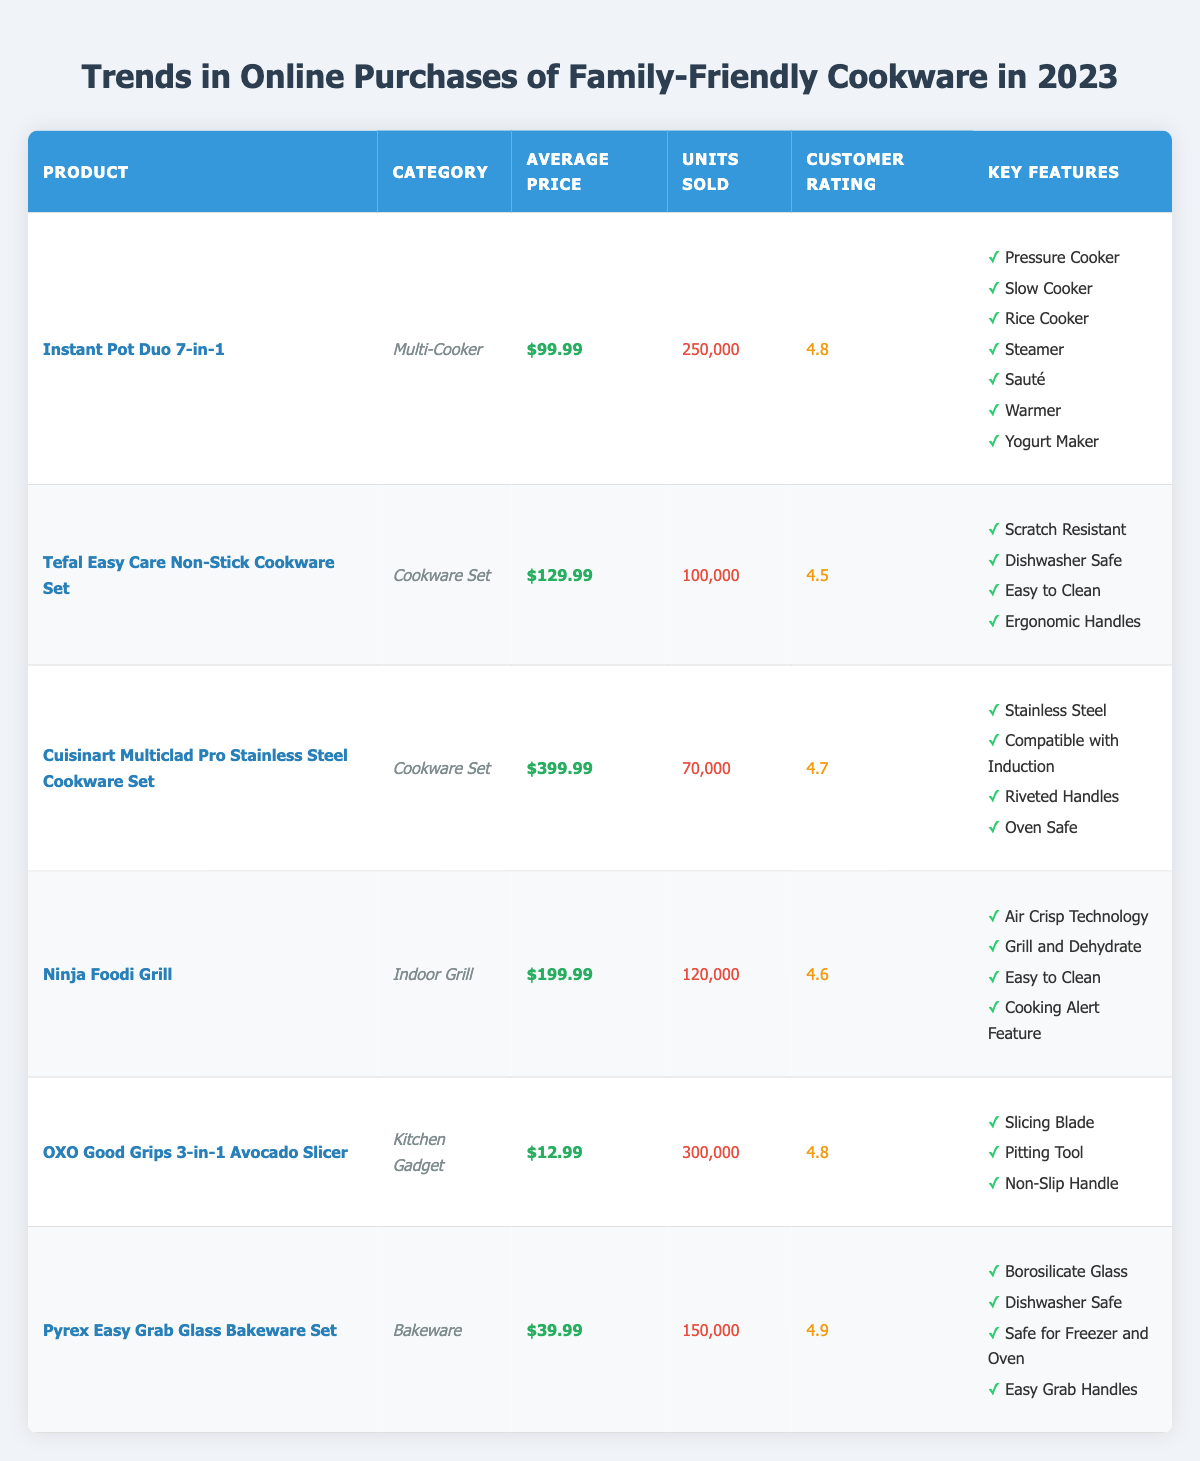What is the average price of the cookware products listed in the table? To find the average price, we need to sum up all the average prices of the products: 99.99 + 129.99 + 399.99 + 199.99 + 12.99 + 39.99 = 882.94. Then, divide by the number of products (6): 882.94 / 6 = 147.16.
Answer: 147.16 Which product has the highest customer rating? By examining the customer ratings, we find that the Pyrex Easy Grab Glass Bakeware Set has the highest rating of 4.9.
Answer: Pyrex Easy Grab Glass Bakeware Set How many units were sold for the Instant Pot Duo 7-in-1? The table directly lists the units sold for the Instant Pot Duo 7-in-1 as 250,000.
Answer: 250,000 Is the Tefal Easy Care Non-Stick Cookware Set rated above 4.6? The customer rating for the Tefal Easy Care Non-Stick Cookware Set is 4.5, which is not above 4.6.
Answer: No What is the difference in units sold between the OXO Good Grips 3-in-1 Avocado Slicer and the Cuisinart Multiclad Pro Stainless Steel Cookware Set? The units sold for the OXO Good Grips 3-in-1 Avocado Slicer is 300,000 and for the Cuisinart Multiclad Pro is 70,000. The difference is 300,000 - 70,000 = 230,000.
Answer: 230,000 What key feature is common between the Instant Pot Duo 7-in-1 and the Ninja Foodi Grill? Both the Instant Pot Duo 7-in-1 and the Ninja Foodi Grill have a key feature that involves cooking versatility: Instant Pot has multiple cooking functions including pressure cooking and sautéing, while Ninja Foodi includes air crisp technology. Both focus on being multi-functional kitchen tools.
Answer: Multiple cooking functions What is the total number of units sold for the cookware sets? The units sold for both cookware sets are: Tefal Easy Care Non-Stick Cookware Set (100,000) and Cuisinart Multiclad Pro Stainless Steel Cookware Set (70,000). Adding these gives a total of 100,000 + 70,000 = 170,000 units sold for the cookware sets.
Answer: 170,000 Which product is the most affordable among those listed? By comparing the average prices, the OXO Good Grips 3-in-1 Avocado Slicer is listed at $12.99, making it the most affordable product in the table.
Answer: OXO Good Grips 3-in-1 Avocado Slicer 